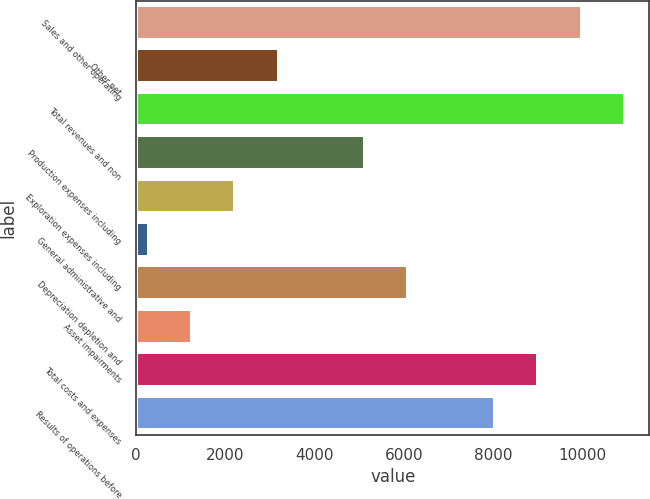Convert chart to OTSL. <chart><loc_0><loc_0><loc_500><loc_500><bar_chart><fcel>Sales and other operating<fcel>Other net<fcel>Total revenues and non<fcel>Production expenses including<fcel>Exploration expenses including<fcel>General administrative and<fcel>Depreciation depletion and<fcel>Asset impairments<fcel>Total costs and expenses<fcel>Results of operations before<nl><fcel>9977<fcel>3189.8<fcel>10946.6<fcel>5129<fcel>2220.2<fcel>281<fcel>6098.6<fcel>1250.6<fcel>9007.4<fcel>8037.8<nl></chart> 